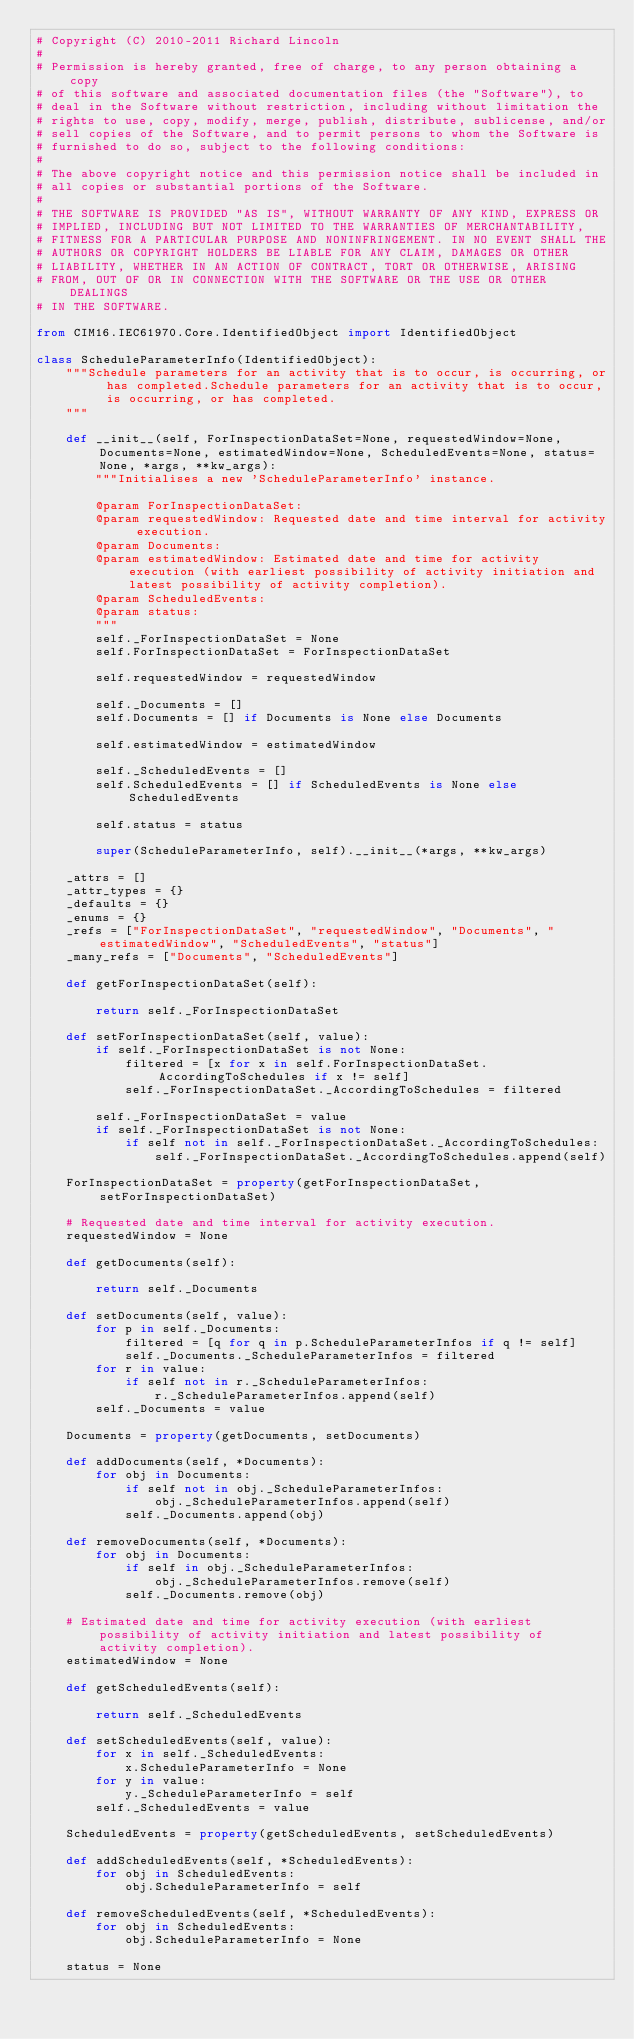Convert code to text. <code><loc_0><loc_0><loc_500><loc_500><_Python_># Copyright (C) 2010-2011 Richard Lincoln
#
# Permission is hereby granted, free of charge, to any person obtaining a copy
# of this software and associated documentation files (the "Software"), to
# deal in the Software without restriction, including without limitation the
# rights to use, copy, modify, merge, publish, distribute, sublicense, and/or
# sell copies of the Software, and to permit persons to whom the Software is
# furnished to do so, subject to the following conditions:
#
# The above copyright notice and this permission notice shall be included in
# all copies or substantial portions of the Software.
#
# THE SOFTWARE IS PROVIDED "AS IS", WITHOUT WARRANTY OF ANY KIND, EXPRESS OR
# IMPLIED, INCLUDING BUT NOT LIMITED TO THE WARRANTIES OF MERCHANTABILITY,
# FITNESS FOR A PARTICULAR PURPOSE AND NONINFRINGEMENT. IN NO EVENT SHALL THE
# AUTHORS OR COPYRIGHT HOLDERS BE LIABLE FOR ANY CLAIM, DAMAGES OR OTHER
# LIABILITY, WHETHER IN AN ACTION OF CONTRACT, TORT OR OTHERWISE, ARISING
# FROM, OUT OF OR IN CONNECTION WITH THE SOFTWARE OR THE USE OR OTHER DEALINGS
# IN THE SOFTWARE.

from CIM16.IEC61970.Core.IdentifiedObject import IdentifiedObject

class ScheduleParameterInfo(IdentifiedObject):
    """Schedule parameters for an activity that is to occur, is occurring, or has completed.Schedule parameters for an activity that is to occur, is occurring, or has completed.
    """

    def __init__(self, ForInspectionDataSet=None, requestedWindow=None, Documents=None, estimatedWindow=None, ScheduledEvents=None, status=None, *args, **kw_args):
        """Initialises a new 'ScheduleParameterInfo' instance.

        @param ForInspectionDataSet:
        @param requestedWindow: Requested date and time interval for activity execution.
        @param Documents:
        @param estimatedWindow: Estimated date and time for activity execution (with earliest possibility of activity initiation and latest possibility of activity completion).
        @param ScheduledEvents:
        @param status:
        """
        self._ForInspectionDataSet = None
        self.ForInspectionDataSet = ForInspectionDataSet

        self.requestedWindow = requestedWindow

        self._Documents = []
        self.Documents = [] if Documents is None else Documents

        self.estimatedWindow = estimatedWindow

        self._ScheduledEvents = []
        self.ScheduledEvents = [] if ScheduledEvents is None else ScheduledEvents

        self.status = status

        super(ScheduleParameterInfo, self).__init__(*args, **kw_args)

    _attrs = []
    _attr_types = {}
    _defaults = {}
    _enums = {}
    _refs = ["ForInspectionDataSet", "requestedWindow", "Documents", "estimatedWindow", "ScheduledEvents", "status"]
    _many_refs = ["Documents", "ScheduledEvents"]

    def getForInspectionDataSet(self):
        
        return self._ForInspectionDataSet

    def setForInspectionDataSet(self, value):
        if self._ForInspectionDataSet is not None:
            filtered = [x for x in self.ForInspectionDataSet.AccordingToSchedules if x != self]
            self._ForInspectionDataSet._AccordingToSchedules = filtered

        self._ForInspectionDataSet = value
        if self._ForInspectionDataSet is not None:
            if self not in self._ForInspectionDataSet._AccordingToSchedules:
                self._ForInspectionDataSet._AccordingToSchedules.append(self)

    ForInspectionDataSet = property(getForInspectionDataSet, setForInspectionDataSet)

    # Requested date and time interval for activity execution.
    requestedWindow = None

    def getDocuments(self):
        
        return self._Documents

    def setDocuments(self, value):
        for p in self._Documents:
            filtered = [q for q in p.ScheduleParameterInfos if q != self]
            self._Documents._ScheduleParameterInfos = filtered
        for r in value:
            if self not in r._ScheduleParameterInfos:
                r._ScheduleParameterInfos.append(self)
        self._Documents = value

    Documents = property(getDocuments, setDocuments)

    def addDocuments(self, *Documents):
        for obj in Documents:
            if self not in obj._ScheduleParameterInfos:
                obj._ScheduleParameterInfos.append(self)
            self._Documents.append(obj)

    def removeDocuments(self, *Documents):
        for obj in Documents:
            if self in obj._ScheduleParameterInfos:
                obj._ScheduleParameterInfos.remove(self)
            self._Documents.remove(obj)

    # Estimated date and time for activity execution (with earliest possibility of activity initiation and latest possibility of activity completion).
    estimatedWindow = None

    def getScheduledEvents(self):
        
        return self._ScheduledEvents

    def setScheduledEvents(self, value):
        for x in self._ScheduledEvents:
            x.ScheduleParameterInfo = None
        for y in value:
            y._ScheduleParameterInfo = self
        self._ScheduledEvents = value

    ScheduledEvents = property(getScheduledEvents, setScheduledEvents)

    def addScheduledEvents(self, *ScheduledEvents):
        for obj in ScheduledEvents:
            obj.ScheduleParameterInfo = self

    def removeScheduledEvents(self, *ScheduledEvents):
        for obj in ScheduledEvents:
            obj.ScheduleParameterInfo = None

    status = None

</code> 